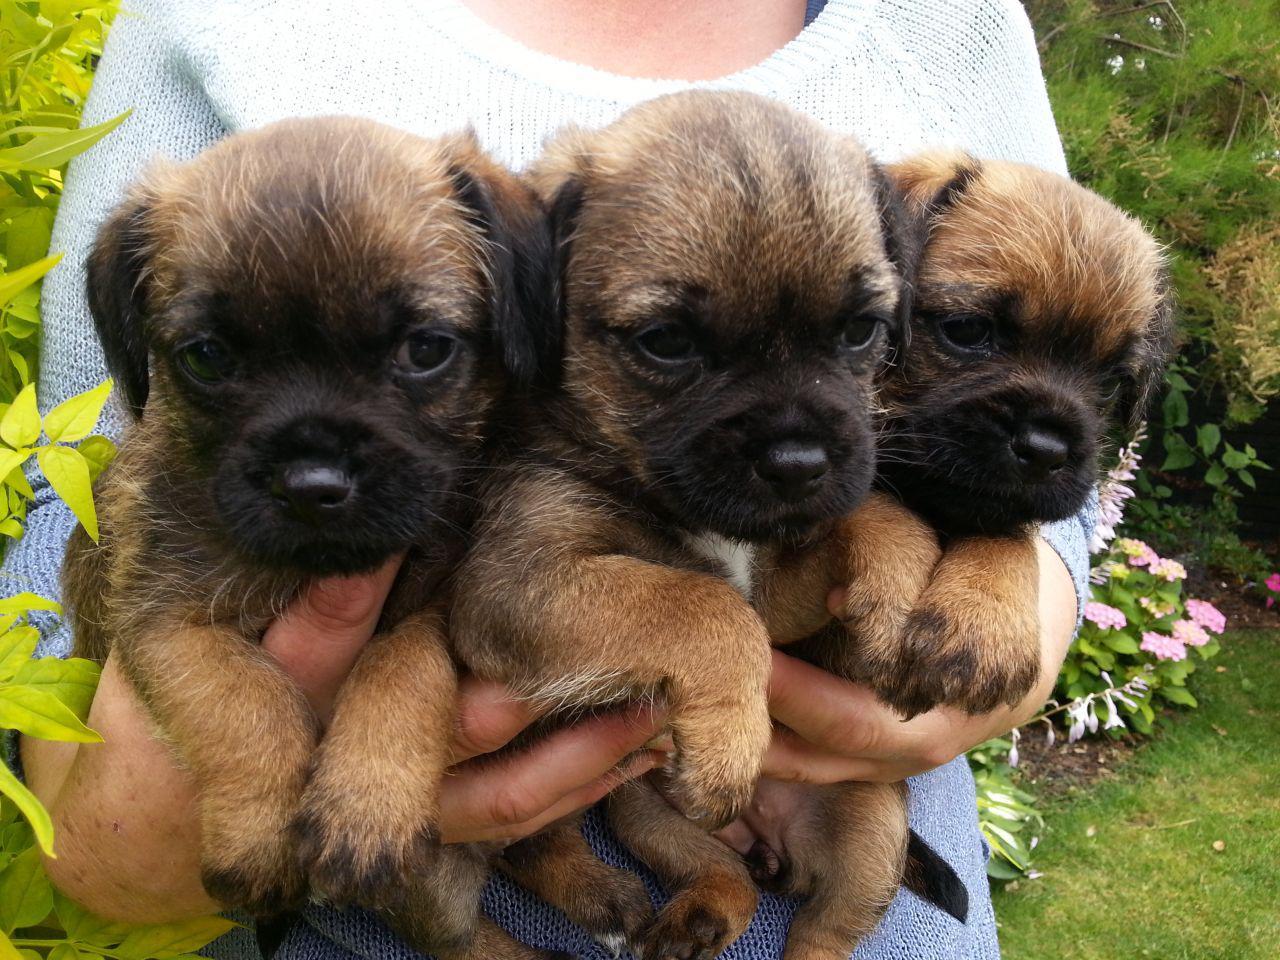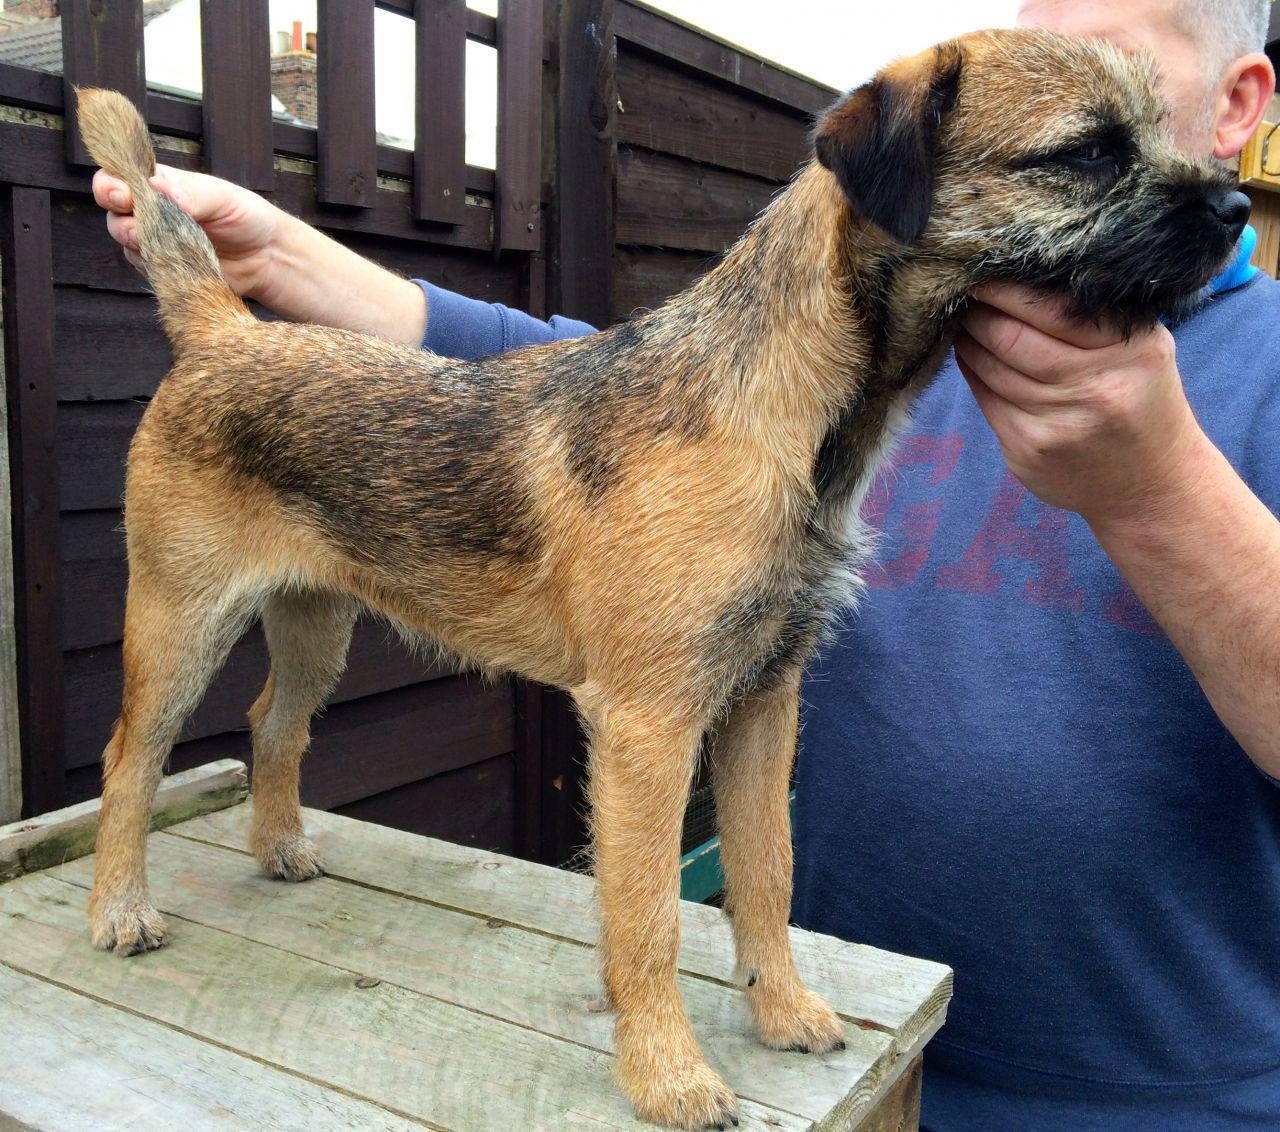The first image is the image on the left, the second image is the image on the right. For the images displayed, is the sentence "Each image shows one person with exactly one dog, and one image shows a person propping the dog's chin with one hand." factually correct? Answer yes or no. No. The first image is the image on the left, the second image is the image on the right. Considering the images on both sides, is "There are at most two dogs." valid? Answer yes or no. No. 